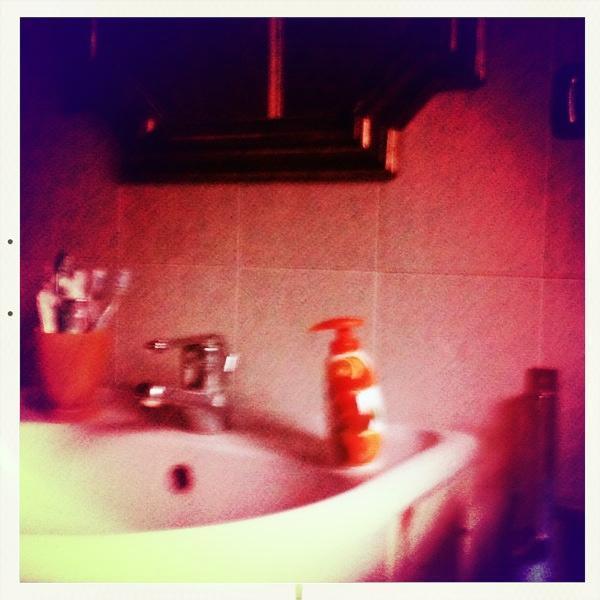How many of the birds are sitting?
Give a very brief answer. 0. 